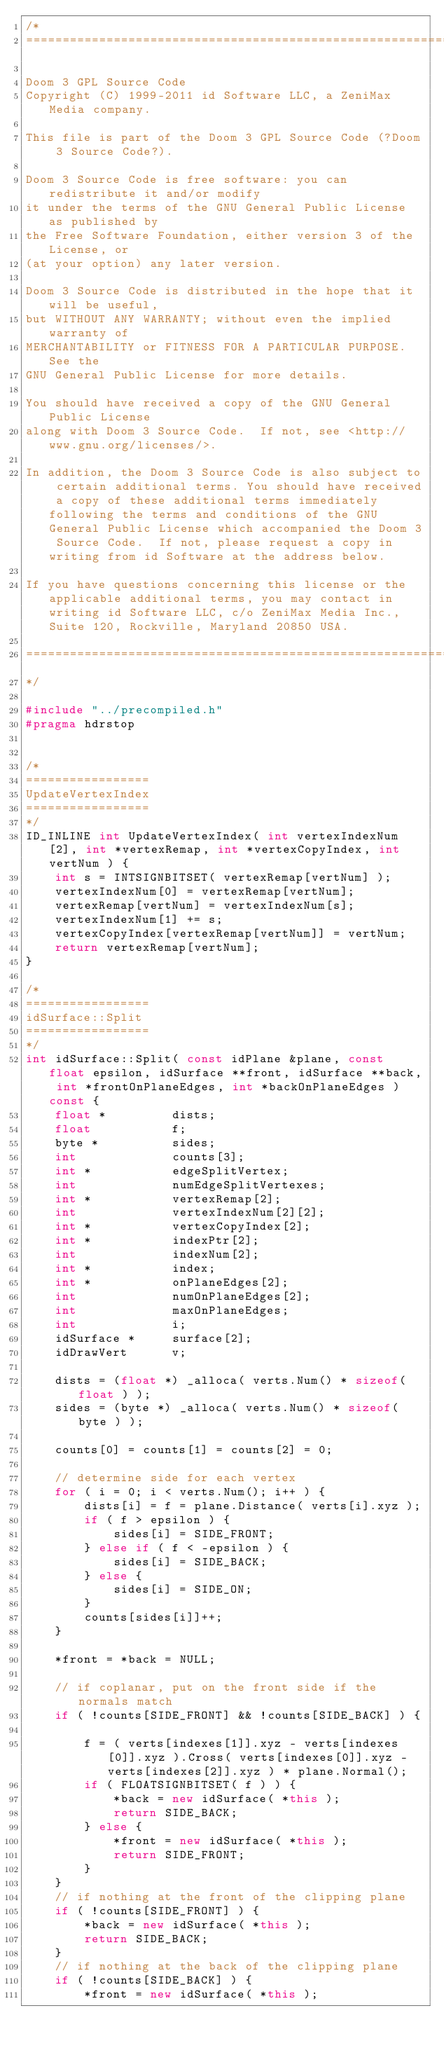Convert code to text. <code><loc_0><loc_0><loc_500><loc_500><_C++_>/*
===========================================================================

Doom 3 GPL Source Code
Copyright (C) 1999-2011 id Software LLC, a ZeniMax Media company. 

This file is part of the Doom 3 GPL Source Code (?Doom 3 Source Code?).  

Doom 3 Source Code is free software: you can redistribute it and/or modify
it under the terms of the GNU General Public License as published by
the Free Software Foundation, either version 3 of the License, or
(at your option) any later version.

Doom 3 Source Code is distributed in the hope that it will be useful,
but WITHOUT ANY WARRANTY; without even the implied warranty of
MERCHANTABILITY or FITNESS FOR A PARTICULAR PURPOSE.  See the
GNU General Public License for more details.

You should have received a copy of the GNU General Public License
along with Doom 3 Source Code.  If not, see <http://www.gnu.org/licenses/>.

In addition, the Doom 3 Source Code is also subject to certain additional terms. You should have received a copy of these additional terms immediately following the terms and conditions of the GNU General Public License which accompanied the Doom 3 Source Code.  If not, please request a copy in writing from id Software at the address below.

If you have questions concerning this license or the applicable additional terms, you may contact in writing id Software LLC, c/o ZeniMax Media Inc., Suite 120, Rockville, Maryland 20850 USA.

===========================================================================
*/

#include "../precompiled.h"
#pragma hdrstop


/*
=================
UpdateVertexIndex
=================
*/
ID_INLINE int UpdateVertexIndex( int vertexIndexNum[2], int *vertexRemap, int *vertexCopyIndex, int vertNum ) {
	int s = INTSIGNBITSET( vertexRemap[vertNum] );
	vertexIndexNum[0] = vertexRemap[vertNum];
	vertexRemap[vertNum] = vertexIndexNum[s];
	vertexIndexNum[1] += s;
	vertexCopyIndex[vertexRemap[vertNum]] = vertNum;
	return vertexRemap[vertNum];
}

/*
=================
idSurface::Split
=================
*/
int idSurface::Split( const idPlane &plane, const float epsilon, idSurface **front, idSurface **back, int *frontOnPlaneEdges, int *backOnPlaneEdges ) const {
	float *			dists;
	float			f;
	byte *			sides;
	int				counts[3];
	int *			edgeSplitVertex;
	int				numEdgeSplitVertexes;
	int *			vertexRemap[2];
	int				vertexIndexNum[2][2];
	int *			vertexCopyIndex[2];
	int *			indexPtr[2];
	int				indexNum[2];
	int *			index;
	int *			onPlaneEdges[2];
	int				numOnPlaneEdges[2];
	int				maxOnPlaneEdges;
	int				i;
	idSurface *		surface[2];
	idDrawVert		v;

	dists = (float *) _alloca( verts.Num() * sizeof( float ) );
	sides = (byte *) _alloca( verts.Num() * sizeof( byte ) );

	counts[0] = counts[1] = counts[2] = 0;

	// determine side for each vertex
	for ( i = 0; i < verts.Num(); i++ ) {
		dists[i] = f = plane.Distance( verts[i].xyz );
		if ( f > epsilon ) {
			sides[i] = SIDE_FRONT;
		} else if ( f < -epsilon ) {
			sides[i] = SIDE_BACK;
		} else {
			sides[i] = SIDE_ON;
		}
		counts[sides[i]]++;
	}
	
	*front = *back = NULL;

	// if coplanar, put on the front side if the normals match
	if ( !counts[SIDE_FRONT] && !counts[SIDE_BACK] ) {

		f = ( verts[indexes[1]].xyz - verts[indexes[0]].xyz ).Cross( verts[indexes[0]].xyz - verts[indexes[2]].xyz ) * plane.Normal();
		if ( FLOATSIGNBITSET( f ) ) {
			*back = new idSurface( *this );
			return SIDE_BACK;
		} else {
			*front = new idSurface( *this );
			return SIDE_FRONT;
		}
	}
	// if nothing at the front of the clipping plane
	if ( !counts[SIDE_FRONT] ) {
		*back = new idSurface( *this );
		return SIDE_BACK;
	}
	// if nothing at the back of the clipping plane
	if ( !counts[SIDE_BACK] ) {
		*front = new idSurface( *this );</code> 